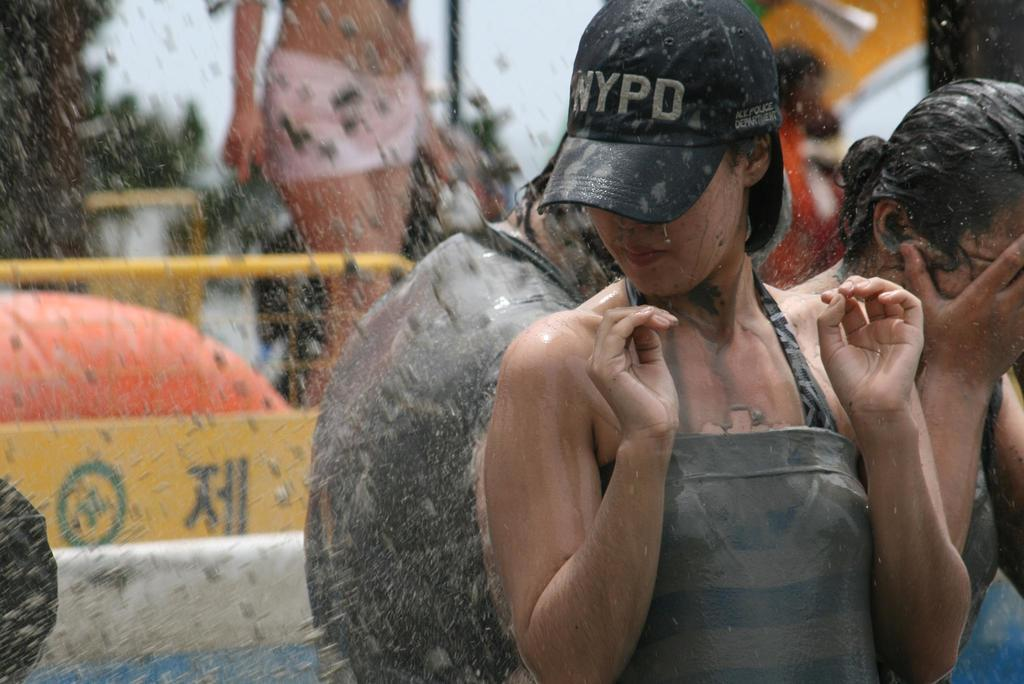Who is the main subject in the image? There is a lady in the center of the image. What is the lady doing in the image? The lady is standing. What is the lady wearing on her head? The lady is wearing a cap. What can be seen in the background of the image? There are persons in the background of the image. What is visible at the top of the image? The sky is visible at the top of the image. How does the lady measure the distance between the train tracks in the image? There is no train or train tracks present in the image, so the lady cannot measure any distances related to them. 